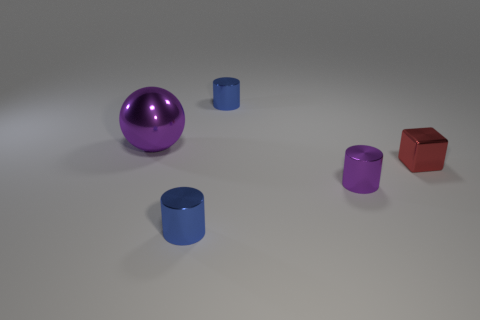Subtract all tiny purple metal cylinders. How many cylinders are left? 2 Subtract all brown balls. How many blue cylinders are left? 2 Subtract all purple cylinders. How many cylinders are left? 2 Add 4 tiny green objects. How many objects exist? 9 Subtract all cubes. How many objects are left? 4 Subtract all yellow cylinders. Subtract all brown balls. How many cylinders are left? 3 Add 5 large purple spheres. How many large purple spheres are left? 6 Add 4 spheres. How many spheres exist? 5 Subtract 1 purple balls. How many objects are left? 4 Subtract all small purple metallic balls. Subtract all big purple balls. How many objects are left? 4 